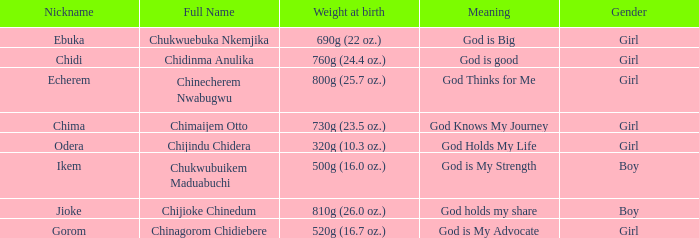How much did the baby who name means God knows my journey weigh at birth? 730g (23.5 oz.). 